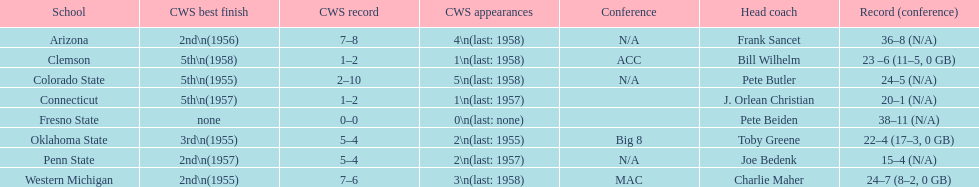Identify the schools with the lowest positions in the cws best finish. Clemson, Colorado State, Connecticut. 